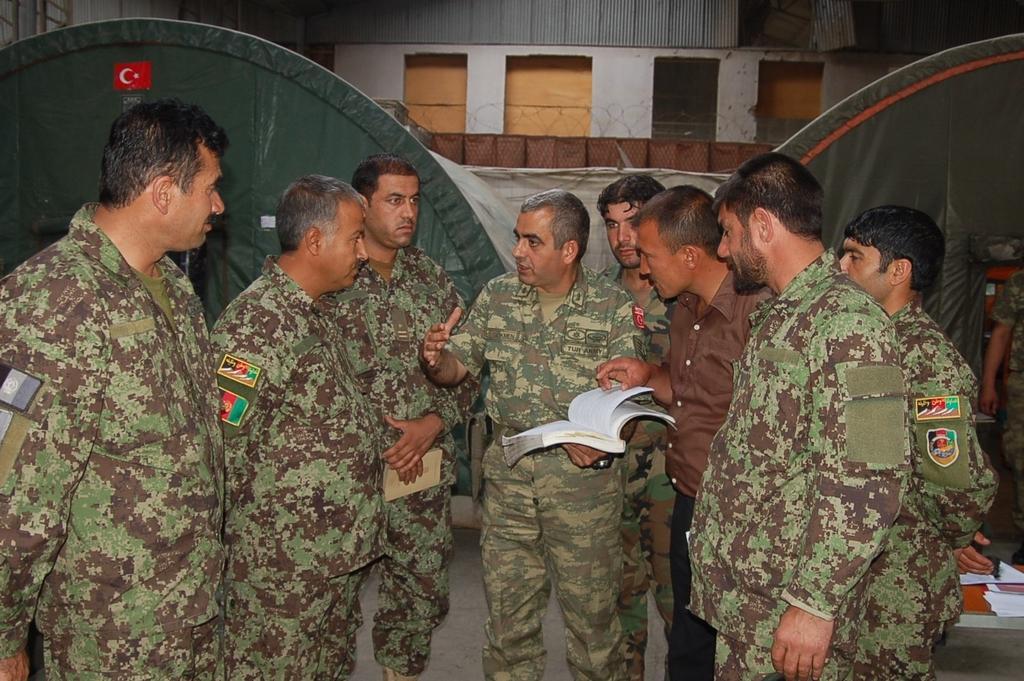Describe this image in one or two sentences. In this image we can see eight persons in uniform and one person in normal dress. There is a person holding the book. In the background there is a building and roofs for shelter. We can also see some papers on the ground. 